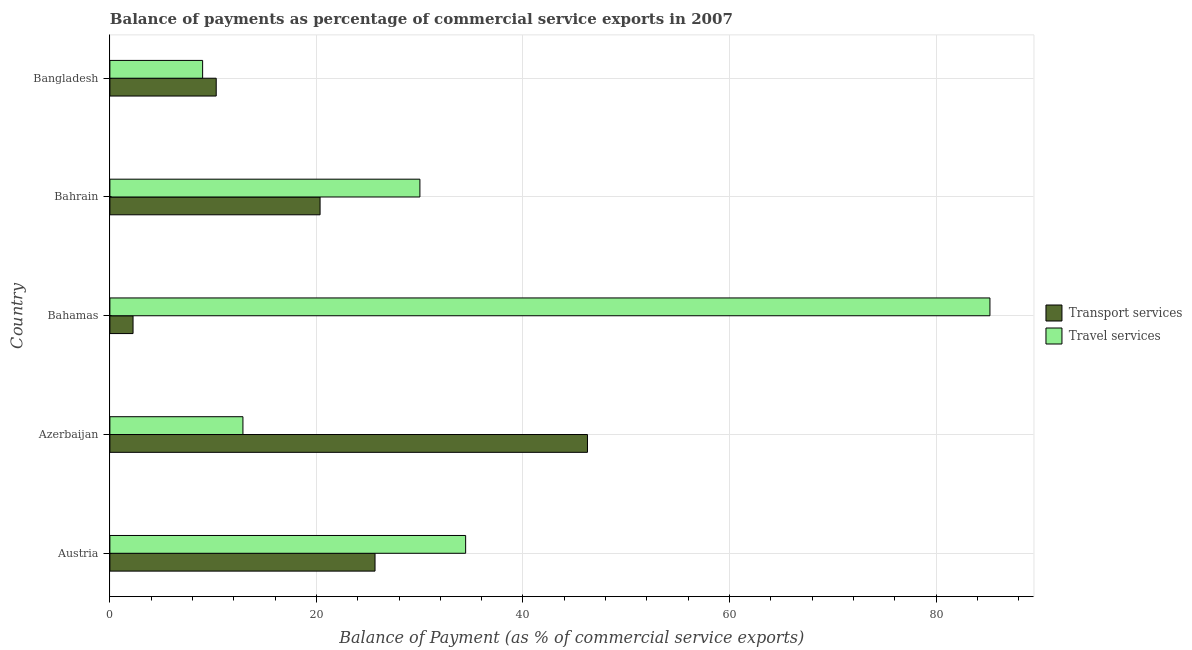How many different coloured bars are there?
Offer a terse response. 2. How many groups of bars are there?
Make the answer very short. 5. Are the number of bars on each tick of the Y-axis equal?
Keep it short and to the point. Yes. How many bars are there on the 5th tick from the top?
Make the answer very short. 2. How many bars are there on the 1st tick from the bottom?
Your response must be concise. 2. What is the label of the 3rd group of bars from the top?
Your response must be concise. Bahamas. What is the balance of payments of travel services in Austria?
Make the answer very short. 34.45. Across all countries, what is the maximum balance of payments of travel services?
Offer a very short reply. 85.22. Across all countries, what is the minimum balance of payments of travel services?
Ensure brevity in your answer.  8.98. In which country was the balance of payments of travel services maximum?
Your answer should be compact. Bahamas. In which country was the balance of payments of transport services minimum?
Your answer should be compact. Bahamas. What is the total balance of payments of transport services in the graph?
Your response must be concise. 104.82. What is the difference between the balance of payments of travel services in Austria and that in Bahrain?
Give a very brief answer. 4.43. What is the difference between the balance of payments of travel services in Bangladesh and the balance of payments of transport services in Austria?
Offer a very short reply. -16.7. What is the average balance of payments of travel services per country?
Give a very brief answer. 34.31. What is the difference between the balance of payments of travel services and balance of payments of transport services in Bangladesh?
Your answer should be compact. -1.32. In how many countries, is the balance of payments of travel services greater than 60 %?
Provide a succinct answer. 1. What is the ratio of the balance of payments of travel services in Austria to that in Bangladesh?
Your response must be concise. 3.84. Is the balance of payments of transport services in Azerbaijan less than that in Bangladesh?
Provide a short and direct response. No. What is the difference between the highest and the second highest balance of payments of transport services?
Your answer should be compact. 20.57. What is the difference between the highest and the lowest balance of payments of transport services?
Offer a terse response. 44.01. In how many countries, is the balance of payments of transport services greater than the average balance of payments of transport services taken over all countries?
Provide a succinct answer. 2. Is the sum of the balance of payments of travel services in Austria and Bahamas greater than the maximum balance of payments of transport services across all countries?
Make the answer very short. Yes. What does the 1st bar from the top in Austria represents?
Ensure brevity in your answer.  Travel services. What does the 2nd bar from the bottom in Austria represents?
Provide a short and direct response. Travel services. How many bars are there?
Provide a short and direct response. 10. How many legend labels are there?
Make the answer very short. 2. What is the title of the graph?
Provide a succinct answer. Balance of payments as percentage of commercial service exports in 2007. Does "Boys" appear as one of the legend labels in the graph?
Make the answer very short. No. What is the label or title of the X-axis?
Give a very brief answer. Balance of Payment (as % of commercial service exports). What is the Balance of Payment (as % of commercial service exports) in Transport services in Austria?
Your response must be concise. 25.68. What is the Balance of Payment (as % of commercial service exports) of Travel services in Austria?
Provide a short and direct response. 34.45. What is the Balance of Payment (as % of commercial service exports) in Transport services in Azerbaijan?
Provide a short and direct response. 46.25. What is the Balance of Payment (as % of commercial service exports) in Travel services in Azerbaijan?
Provide a short and direct response. 12.88. What is the Balance of Payment (as % of commercial service exports) in Transport services in Bahamas?
Provide a short and direct response. 2.24. What is the Balance of Payment (as % of commercial service exports) in Travel services in Bahamas?
Keep it short and to the point. 85.22. What is the Balance of Payment (as % of commercial service exports) of Transport services in Bahrain?
Your answer should be very brief. 20.35. What is the Balance of Payment (as % of commercial service exports) of Travel services in Bahrain?
Your response must be concise. 30.02. What is the Balance of Payment (as % of commercial service exports) of Transport services in Bangladesh?
Your response must be concise. 10.3. What is the Balance of Payment (as % of commercial service exports) of Travel services in Bangladesh?
Provide a succinct answer. 8.98. Across all countries, what is the maximum Balance of Payment (as % of commercial service exports) of Transport services?
Your answer should be compact. 46.25. Across all countries, what is the maximum Balance of Payment (as % of commercial service exports) of Travel services?
Offer a very short reply. 85.22. Across all countries, what is the minimum Balance of Payment (as % of commercial service exports) of Transport services?
Ensure brevity in your answer.  2.24. Across all countries, what is the minimum Balance of Payment (as % of commercial service exports) of Travel services?
Offer a very short reply. 8.98. What is the total Balance of Payment (as % of commercial service exports) of Transport services in the graph?
Offer a terse response. 104.82. What is the total Balance of Payment (as % of commercial service exports) in Travel services in the graph?
Offer a terse response. 171.56. What is the difference between the Balance of Payment (as % of commercial service exports) in Transport services in Austria and that in Azerbaijan?
Ensure brevity in your answer.  -20.57. What is the difference between the Balance of Payment (as % of commercial service exports) of Travel services in Austria and that in Azerbaijan?
Ensure brevity in your answer.  21.57. What is the difference between the Balance of Payment (as % of commercial service exports) of Transport services in Austria and that in Bahamas?
Offer a very short reply. 23.43. What is the difference between the Balance of Payment (as % of commercial service exports) in Travel services in Austria and that in Bahamas?
Give a very brief answer. -50.77. What is the difference between the Balance of Payment (as % of commercial service exports) of Transport services in Austria and that in Bahrain?
Provide a short and direct response. 5.32. What is the difference between the Balance of Payment (as % of commercial service exports) of Travel services in Austria and that in Bahrain?
Offer a terse response. 4.43. What is the difference between the Balance of Payment (as % of commercial service exports) in Transport services in Austria and that in Bangladesh?
Offer a very short reply. 15.38. What is the difference between the Balance of Payment (as % of commercial service exports) in Travel services in Austria and that in Bangladesh?
Give a very brief answer. 25.47. What is the difference between the Balance of Payment (as % of commercial service exports) of Transport services in Azerbaijan and that in Bahamas?
Make the answer very short. 44.01. What is the difference between the Balance of Payment (as % of commercial service exports) in Travel services in Azerbaijan and that in Bahamas?
Your response must be concise. -72.34. What is the difference between the Balance of Payment (as % of commercial service exports) in Transport services in Azerbaijan and that in Bahrain?
Your answer should be compact. 25.89. What is the difference between the Balance of Payment (as % of commercial service exports) of Travel services in Azerbaijan and that in Bahrain?
Give a very brief answer. -17.14. What is the difference between the Balance of Payment (as % of commercial service exports) in Transport services in Azerbaijan and that in Bangladesh?
Your answer should be very brief. 35.95. What is the difference between the Balance of Payment (as % of commercial service exports) of Travel services in Azerbaijan and that in Bangladesh?
Make the answer very short. 3.9. What is the difference between the Balance of Payment (as % of commercial service exports) of Transport services in Bahamas and that in Bahrain?
Make the answer very short. -18.11. What is the difference between the Balance of Payment (as % of commercial service exports) of Travel services in Bahamas and that in Bahrain?
Offer a very short reply. 55.2. What is the difference between the Balance of Payment (as % of commercial service exports) of Transport services in Bahamas and that in Bangladesh?
Offer a very short reply. -8.06. What is the difference between the Balance of Payment (as % of commercial service exports) in Travel services in Bahamas and that in Bangladesh?
Offer a terse response. 76.24. What is the difference between the Balance of Payment (as % of commercial service exports) of Transport services in Bahrain and that in Bangladesh?
Provide a succinct answer. 10.06. What is the difference between the Balance of Payment (as % of commercial service exports) in Travel services in Bahrain and that in Bangladesh?
Offer a terse response. 21.04. What is the difference between the Balance of Payment (as % of commercial service exports) of Transport services in Austria and the Balance of Payment (as % of commercial service exports) of Travel services in Azerbaijan?
Make the answer very short. 12.79. What is the difference between the Balance of Payment (as % of commercial service exports) in Transport services in Austria and the Balance of Payment (as % of commercial service exports) in Travel services in Bahamas?
Ensure brevity in your answer.  -59.55. What is the difference between the Balance of Payment (as % of commercial service exports) of Transport services in Austria and the Balance of Payment (as % of commercial service exports) of Travel services in Bahrain?
Offer a very short reply. -4.35. What is the difference between the Balance of Payment (as % of commercial service exports) of Transport services in Austria and the Balance of Payment (as % of commercial service exports) of Travel services in Bangladesh?
Provide a succinct answer. 16.7. What is the difference between the Balance of Payment (as % of commercial service exports) of Transport services in Azerbaijan and the Balance of Payment (as % of commercial service exports) of Travel services in Bahamas?
Your answer should be very brief. -38.97. What is the difference between the Balance of Payment (as % of commercial service exports) of Transport services in Azerbaijan and the Balance of Payment (as % of commercial service exports) of Travel services in Bahrain?
Offer a terse response. 16.23. What is the difference between the Balance of Payment (as % of commercial service exports) in Transport services in Azerbaijan and the Balance of Payment (as % of commercial service exports) in Travel services in Bangladesh?
Offer a terse response. 37.27. What is the difference between the Balance of Payment (as % of commercial service exports) in Transport services in Bahamas and the Balance of Payment (as % of commercial service exports) in Travel services in Bahrain?
Your answer should be compact. -27.78. What is the difference between the Balance of Payment (as % of commercial service exports) of Transport services in Bahamas and the Balance of Payment (as % of commercial service exports) of Travel services in Bangladesh?
Provide a succinct answer. -6.74. What is the difference between the Balance of Payment (as % of commercial service exports) of Transport services in Bahrain and the Balance of Payment (as % of commercial service exports) of Travel services in Bangladesh?
Make the answer very short. 11.37. What is the average Balance of Payment (as % of commercial service exports) of Transport services per country?
Your answer should be very brief. 20.96. What is the average Balance of Payment (as % of commercial service exports) in Travel services per country?
Ensure brevity in your answer.  34.31. What is the difference between the Balance of Payment (as % of commercial service exports) of Transport services and Balance of Payment (as % of commercial service exports) of Travel services in Austria?
Keep it short and to the point. -8.77. What is the difference between the Balance of Payment (as % of commercial service exports) in Transport services and Balance of Payment (as % of commercial service exports) in Travel services in Azerbaijan?
Offer a very short reply. 33.36. What is the difference between the Balance of Payment (as % of commercial service exports) in Transport services and Balance of Payment (as % of commercial service exports) in Travel services in Bahamas?
Offer a terse response. -82.98. What is the difference between the Balance of Payment (as % of commercial service exports) in Transport services and Balance of Payment (as % of commercial service exports) in Travel services in Bahrain?
Ensure brevity in your answer.  -9.67. What is the difference between the Balance of Payment (as % of commercial service exports) of Transport services and Balance of Payment (as % of commercial service exports) of Travel services in Bangladesh?
Ensure brevity in your answer.  1.32. What is the ratio of the Balance of Payment (as % of commercial service exports) in Transport services in Austria to that in Azerbaijan?
Give a very brief answer. 0.56. What is the ratio of the Balance of Payment (as % of commercial service exports) of Travel services in Austria to that in Azerbaijan?
Offer a very short reply. 2.67. What is the ratio of the Balance of Payment (as % of commercial service exports) in Transport services in Austria to that in Bahamas?
Make the answer very short. 11.45. What is the ratio of the Balance of Payment (as % of commercial service exports) in Travel services in Austria to that in Bahamas?
Keep it short and to the point. 0.4. What is the ratio of the Balance of Payment (as % of commercial service exports) in Transport services in Austria to that in Bahrain?
Provide a succinct answer. 1.26. What is the ratio of the Balance of Payment (as % of commercial service exports) in Travel services in Austria to that in Bahrain?
Your response must be concise. 1.15. What is the ratio of the Balance of Payment (as % of commercial service exports) of Transport services in Austria to that in Bangladesh?
Ensure brevity in your answer.  2.49. What is the ratio of the Balance of Payment (as % of commercial service exports) of Travel services in Austria to that in Bangladesh?
Provide a short and direct response. 3.84. What is the ratio of the Balance of Payment (as % of commercial service exports) in Transport services in Azerbaijan to that in Bahamas?
Ensure brevity in your answer.  20.63. What is the ratio of the Balance of Payment (as % of commercial service exports) of Travel services in Azerbaijan to that in Bahamas?
Keep it short and to the point. 0.15. What is the ratio of the Balance of Payment (as % of commercial service exports) in Transport services in Azerbaijan to that in Bahrain?
Offer a terse response. 2.27. What is the ratio of the Balance of Payment (as % of commercial service exports) in Travel services in Azerbaijan to that in Bahrain?
Make the answer very short. 0.43. What is the ratio of the Balance of Payment (as % of commercial service exports) of Transport services in Azerbaijan to that in Bangladesh?
Make the answer very short. 4.49. What is the ratio of the Balance of Payment (as % of commercial service exports) of Travel services in Azerbaijan to that in Bangladesh?
Give a very brief answer. 1.43. What is the ratio of the Balance of Payment (as % of commercial service exports) of Transport services in Bahamas to that in Bahrain?
Offer a very short reply. 0.11. What is the ratio of the Balance of Payment (as % of commercial service exports) of Travel services in Bahamas to that in Bahrain?
Ensure brevity in your answer.  2.84. What is the ratio of the Balance of Payment (as % of commercial service exports) in Transport services in Bahamas to that in Bangladesh?
Offer a terse response. 0.22. What is the ratio of the Balance of Payment (as % of commercial service exports) in Travel services in Bahamas to that in Bangladesh?
Keep it short and to the point. 9.49. What is the ratio of the Balance of Payment (as % of commercial service exports) in Transport services in Bahrain to that in Bangladesh?
Offer a terse response. 1.98. What is the ratio of the Balance of Payment (as % of commercial service exports) in Travel services in Bahrain to that in Bangladesh?
Provide a short and direct response. 3.34. What is the difference between the highest and the second highest Balance of Payment (as % of commercial service exports) of Transport services?
Your answer should be very brief. 20.57. What is the difference between the highest and the second highest Balance of Payment (as % of commercial service exports) of Travel services?
Your response must be concise. 50.77. What is the difference between the highest and the lowest Balance of Payment (as % of commercial service exports) in Transport services?
Keep it short and to the point. 44.01. What is the difference between the highest and the lowest Balance of Payment (as % of commercial service exports) of Travel services?
Give a very brief answer. 76.24. 